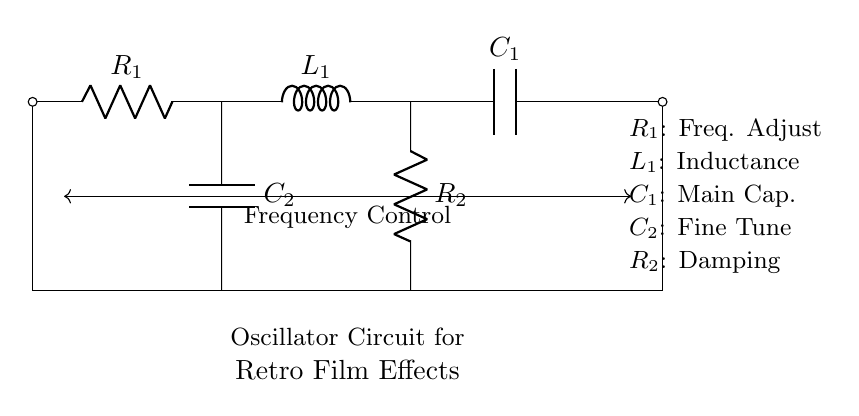What are the main components of this circuit? The main components are a resistor, an inductor, and two capacitors. The diagram labels these components as R1, L1, C1, C2, and R2.
Answer: resistor, inductor, capacitor What is the purpose of R1 in the circuit? R1 is labeled as the frequency adjust component; therefore, it is used to control the frequency output of the oscillator circuit.
Answer: frequency adjust Which component provides damping in the circuit? R2 is indicated as the damping component; its role is to reduce oscillations and stabilize the circuit.
Answer: damping What type of oscillator is this circuit primarily used for? The circuit is labeled specifically for retro film effects; this suggests it is tailored for vintage-style signal generation.
Answer: retro film effects How many capacitors are present in the circuit? The diagram clearly shows two capacitors labeled C1 and C2, indicating that there are two capacitors present in the circuit.
Answer: two What is the main function of L1 in this oscillator circuit? L1 is labeled as inductance in the circuit, which indicates its primary role is to store energy in a magnetic field and determine the oscillation characteristics.
Answer: inductance How is frequency control achieved in this circuit? The frequency control is noted as being from R1, and it likely works in conjunction with L1 and C1 to adjust the oscillation frequency through resistance changes.
Answer: R1 